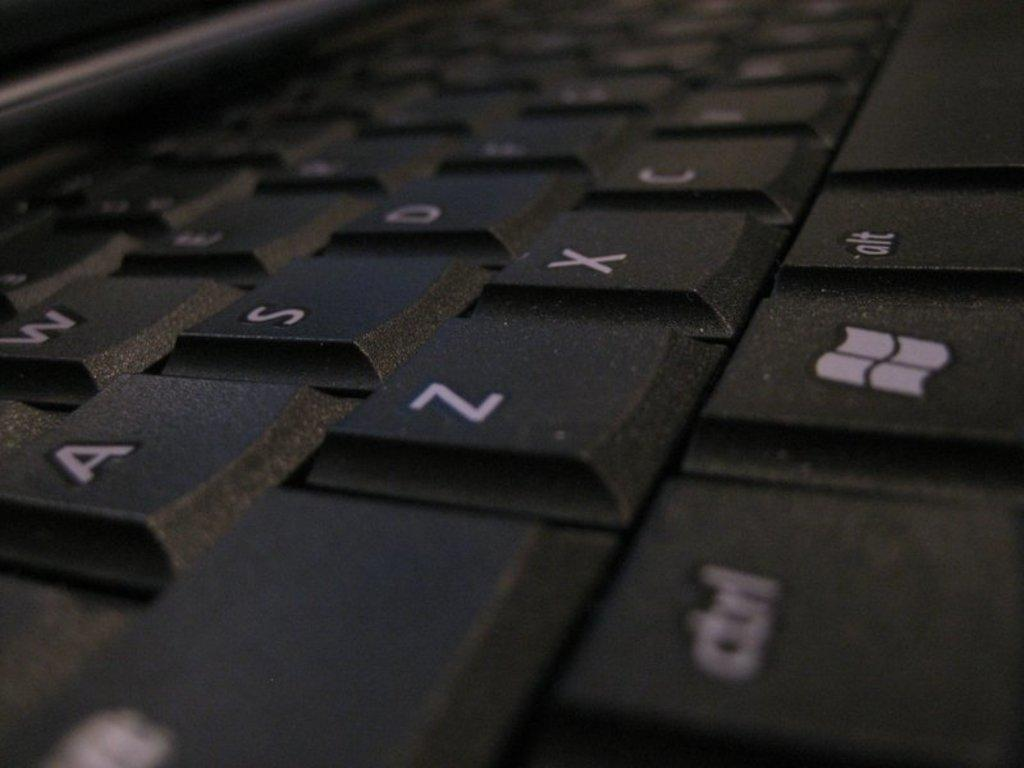<image>
Relay a brief, clear account of the picture shown. a close up of a black key board with keys A and Z 